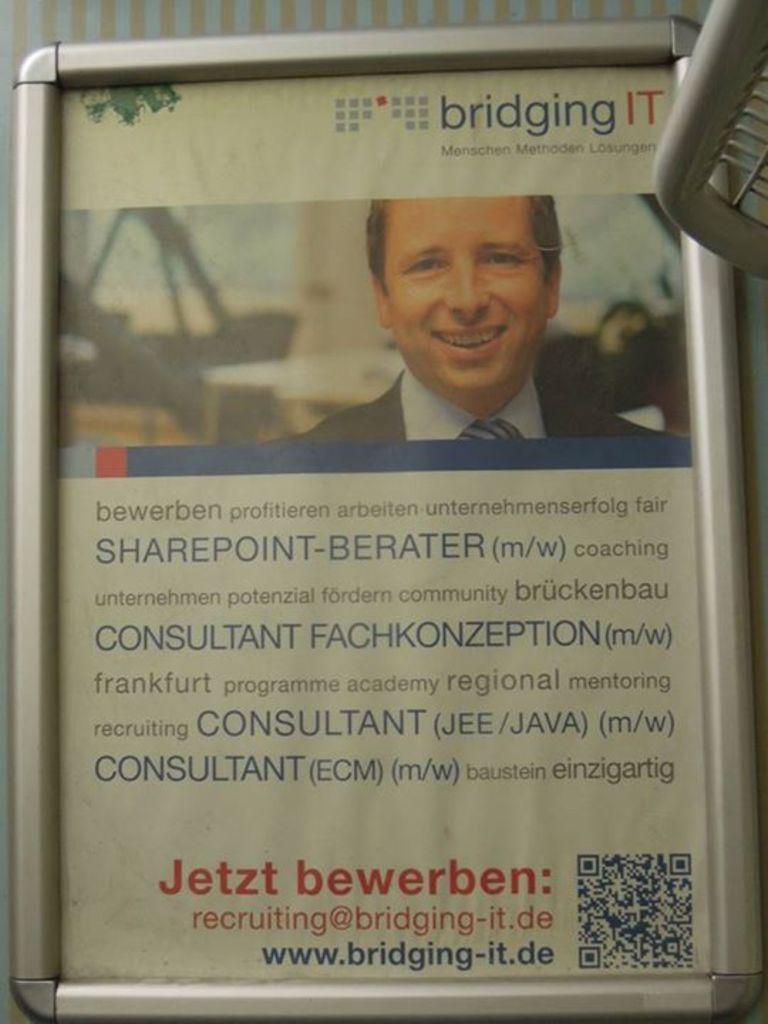Please provide a concise description of this image. Here we can see a poster in a frame on a platform. On the right at the top corner there is an object and on the poster we can see a man picture and texts written on it. 